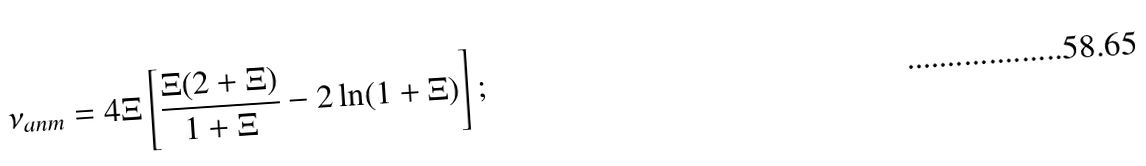Convert formula to latex. <formula><loc_0><loc_0><loc_500><loc_500>\nu _ { a n m } = 4 \Xi \left [ \frac { \Xi ( 2 + \Xi ) } { 1 + \Xi } - 2 \ln ( 1 + \Xi ) \right ] ;</formula> 